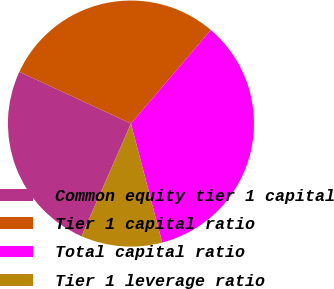<chart> <loc_0><loc_0><loc_500><loc_500><pie_chart><fcel>Common equity tier 1 capital<fcel>Tier 1 capital ratio<fcel>Total capital ratio<fcel>Tier 1 leverage ratio<nl><fcel>25.33%<fcel>29.33%<fcel>34.67%<fcel>10.67%<nl></chart> 